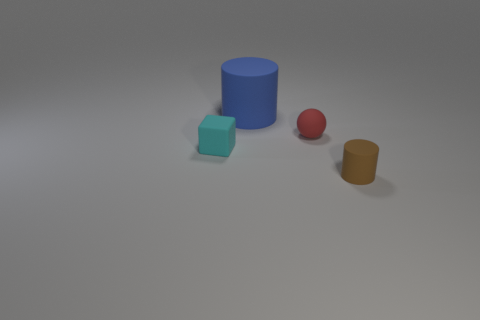Add 4 tiny brown cylinders. How many objects exist? 8 Subtract all brown cylinders. How many cylinders are left? 1 Subtract all blocks. How many objects are left? 3 Add 3 small red things. How many small red things are left? 4 Add 2 cyan blocks. How many cyan blocks exist? 3 Subtract 0 brown blocks. How many objects are left? 4 Subtract 2 cylinders. How many cylinders are left? 0 Subtract all blue cylinders. Subtract all purple spheres. How many cylinders are left? 1 Subtract all big shiny objects. Subtract all big blue things. How many objects are left? 3 